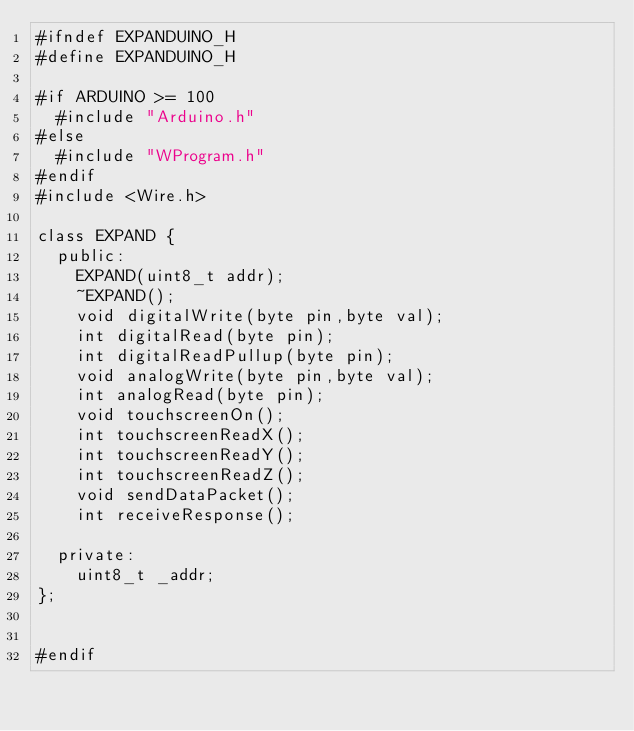<code> <loc_0><loc_0><loc_500><loc_500><_C_>#ifndef EXPANDUINO_H
#define EXPANDUINO_H
     
#if ARDUINO >= 100
  #include "Arduino.h"
#else
  #include "WProgram.h"
#endif
#include <Wire.h>

class EXPAND {
  public:
    EXPAND(uint8_t addr);
    ~EXPAND();
    void digitalWrite(byte pin,byte val);
    int digitalRead(byte pin);
    int digitalReadPullup(byte pin);
    void analogWrite(byte pin,byte val);
    int analogRead(byte pin);
	void touchscreenOn();
	int touchscreenReadX();
	int touchscreenReadY();
	int touchscreenReadZ();
    void sendDataPacket();
    int receiveResponse();
	
  private:
    uint8_t _addr;
};


#endif

</code> 